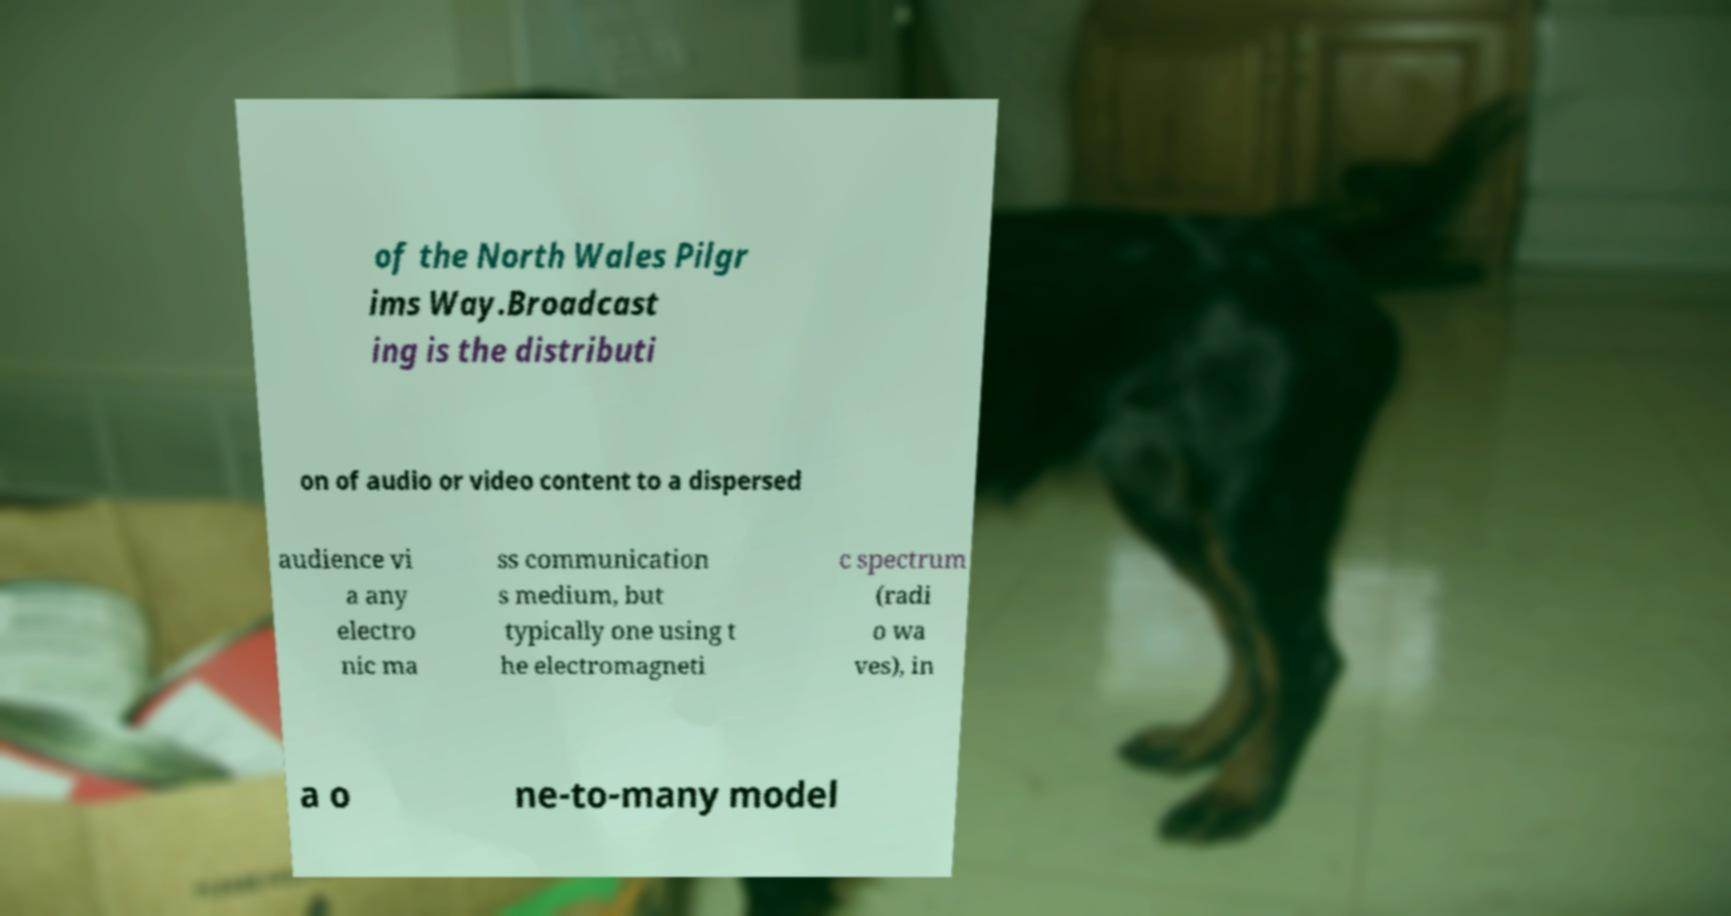Can you accurately transcribe the text from the provided image for me? of the North Wales Pilgr ims Way.Broadcast ing is the distributi on of audio or video content to a dispersed audience vi a any electro nic ma ss communication s medium, but typically one using t he electromagneti c spectrum (radi o wa ves), in a o ne-to-many model 